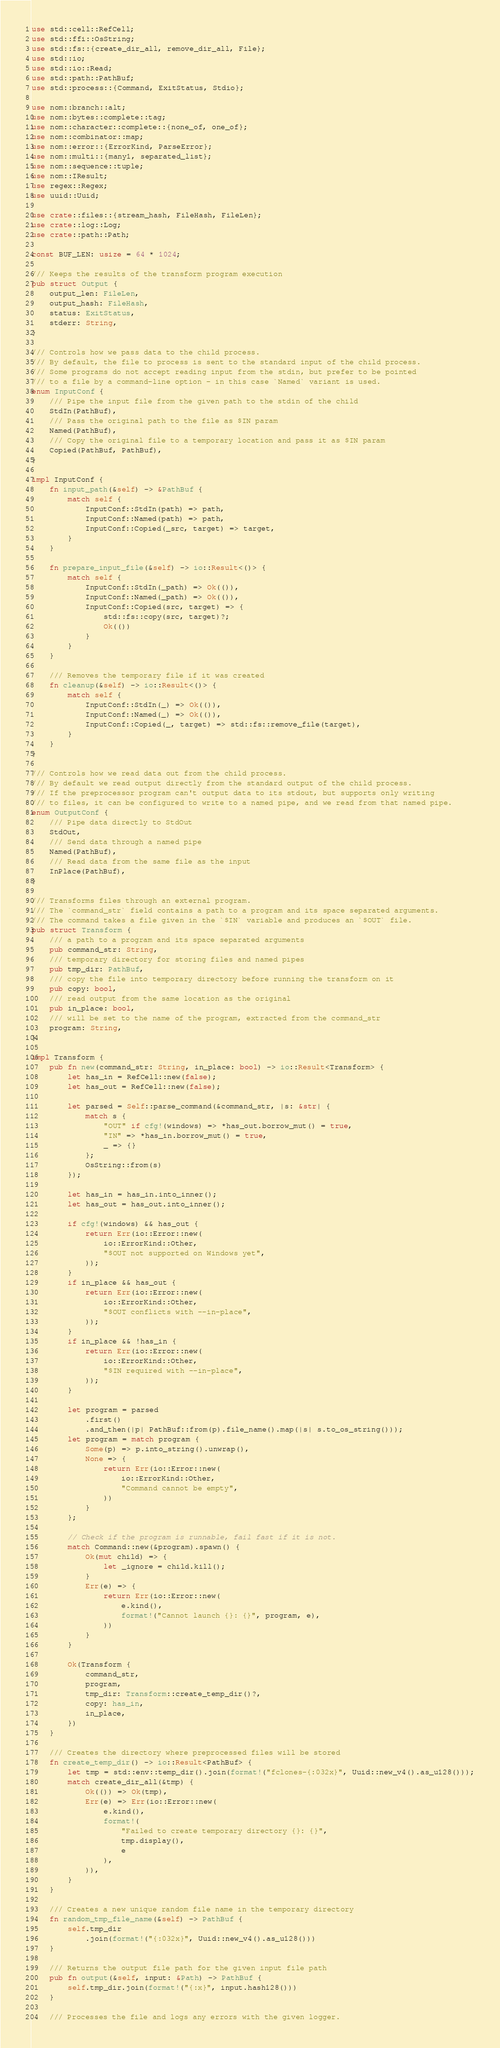<code> <loc_0><loc_0><loc_500><loc_500><_Rust_>use std::cell::RefCell;
use std::ffi::OsString;
use std::fs::{create_dir_all, remove_dir_all, File};
use std::io;
use std::io::Read;
use std::path::PathBuf;
use std::process::{Command, ExitStatus, Stdio};

use nom::branch::alt;
use nom::bytes::complete::tag;
use nom::character::complete::{none_of, one_of};
use nom::combinator::map;
use nom::error::{ErrorKind, ParseError};
use nom::multi::{many1, separated_list};
use nom::sequence::tuple;
use nom::IResult;
use regex::Regex;
use uuid::Uuid;

use crate::files::{stream_hash, FileHash, FileLen};
use crate::log::Log;
use crate::path::Path;

const BUF_LEN: usize = 64 * 1024;

/// Keeps the results of the transform program execution
pub struct Output {
    output_len: FileLen,
    output_hash: FileHash,
    status: ExitStatus,
    stderr: String,
}

/// Controls how we pass data to the child process.
/// By default, the file to process is sent to the standard input of the child process.
/// Some programs do not accept reading input from the stdin, but prefer to be pointed
/// to a file by a command-line option - in this case `Named` variant is used.
enum InputConf {
    /// Pipe the input file from the given path to the stdin of the child
    StdIn(PathBuf),
    /// Pass the original path to the file as $IN param
    Named(PathBuf),
    /// Copy the original file to a temporary location and pass it as $IN param
    Copied(PathBuf, PathBuf),
}

impl InputConf {
    fn input_path(&self) -> &PathBuf {
        match self {
            InputConf::StdIn(path) => path,
            InputConf::Named(path) => path,
            InputConf::Copied(_src, target) => target,
        }
    }

    fn prepare_input_file(&self) -> io::Result<()> {
        match self {
            InputConf::StdIn(_path) => Ok(()),
            InputConf::Named(_path) => Ok(()),
            InputConf::Copied(src, target) => {
                std::fs::copy(src, target)?;
                Ok(())
            }
        }
    }

    /// Removes the temporary file if it was created
    fn cleanup(&self) -> io::Result<()> {
        match self {
            InputConf::StdIn(_) => Ok(()),
            InputConf::Named(_) => Ok(()),
            InputConf::Copied(_, target) => std::fs::remove_file(target),
        }
    }
}

/// Controls how we read data out from the child process.
/// By default we read output directly from the standard output of the child process.
/// If the preprocessor program can't output data to its stdout, but supports only writing
/// to files, it can be configured to write to a named pipe, and we read from that named pipe.
enum OutputConf {
    /// Pipe data directly to StdOut
    StdOut,
    /// Send data through a named pipe
    Named(PathBuf),
    /// Read data from the same file as the input
    InPlace(PathBuf),
}

/// Transforms files through an external program.
/// The `command_str` field contains a path to a program and its space separated arguments.
/// The command takes a file given in the `$IN` variable and produces an `$OUT` file.
pub struct Transform {
    /// a path to a program and its space separated arguments
    pub command_str: String,
    /// temporary directory for storing files and named pipes
    pub tmp_dir: PathBuf,
    /// copy the file into temporary directory before running the transform on it
    pub copy: bool,
    /// read output from the same location as the original
    pub in_place: bool,
    /// will be set to the name of the program, extracted from the command_str
    program: String,
}

impl Transform {
    pub fn new(command_str: String, in_place: bool) -> io::Result<Transform> {
        let has_in = RefCell::new(false);
        let has_out = RefCell::new(false);

        let parsed = Self::parse_command(&command_str, |s: &str| {
            match s {
                "OUT" if cfg!(windows) => *has_out.borrow_mut() = true,
                "IN" => *has_in.borrow_mut() = true,
                _ => {}
            };
            OsString::from(s)
        });

        let has_in = has_in.into_inner();
        let has_out = has_out.into_inner();

        if cfg!(windows) && has_out {
            return Err(io::Error::new(
                io::ErrorKind::Other,
                "$OUT not supported on Windows yet",
            ));
        }
        if in_place && has_out {
            return Err(io::Error::new(
                io::ErrorKind::Other,
                "$OUT conflicts with --in-place",
            ));
        }
        if in_place && !has_in {
            return Err(io::Error::new(
                io::ErrorKind::Other,
                "$IN required with --in-place",
            ));
        }

        let program = parsed
            .first()
            .and_then(|p| PathBuf::from(p).file_name().map(|s| s.to_os_string()));
        let program = match program {
            Some(p) => p.into_string().unwrap(),
            None => {
                return Err(io::Error::new(
                    io::ErrorKind::Other,
                    "Command cannot be empty",
                ))
            }
        };

        // Check if the program is runnable, fail fast if it is not.
        match Command::new(&program).spawn() {
            Ok(mut child) => {
                let _ignore = child.kill();
            }
            Err(e) => {
                return Err(io::Error::new(
                    e.kind(),
                    format!("Cannot launch {}: {}", program, e),
                ))
            }
        }

        Ok(Transform {
            command_str,
            program,
            tmp_dir: Transform::create_temp_dir()?,
            copy: has_in,
            in_place,
        })
    }

    /// Creates the directory where preprocessed files will be stored
    fn create_temp_dir() -> io::Result<PathBuf> {
        let tmp = std::env::temp_dir().join(format!("fclones-{:032x}", Uuid::new_v4().as_u128()));
        match create_dir_all(&tmp) {
            Ok(()) => Ok(tmp),
            Err(e) => Err(io::Error::new(
                e.kind(),
                format!(
                    "Failed to create temporary directory {}: {}",
                    tmp.display(),
                    e
                ),
            )),
        }
    }

    /// Creates a new unique random file name in the temporary directory
    fn random_tmp_file_name(&self) -> PathBuf {
        self.tmp_dir
            .join(format!("{:032x}", Uuid::new_v4().as_u128()))
    }

    /// Returns the output file path for the given input file path
    pub fn output(&self, input: &Path) -> PathBuf {
        self.tmp_dir.join(format!("{:x}", input.hash128()))
    }

    /// Processes the file and logs any errors with the given logger.</code> 